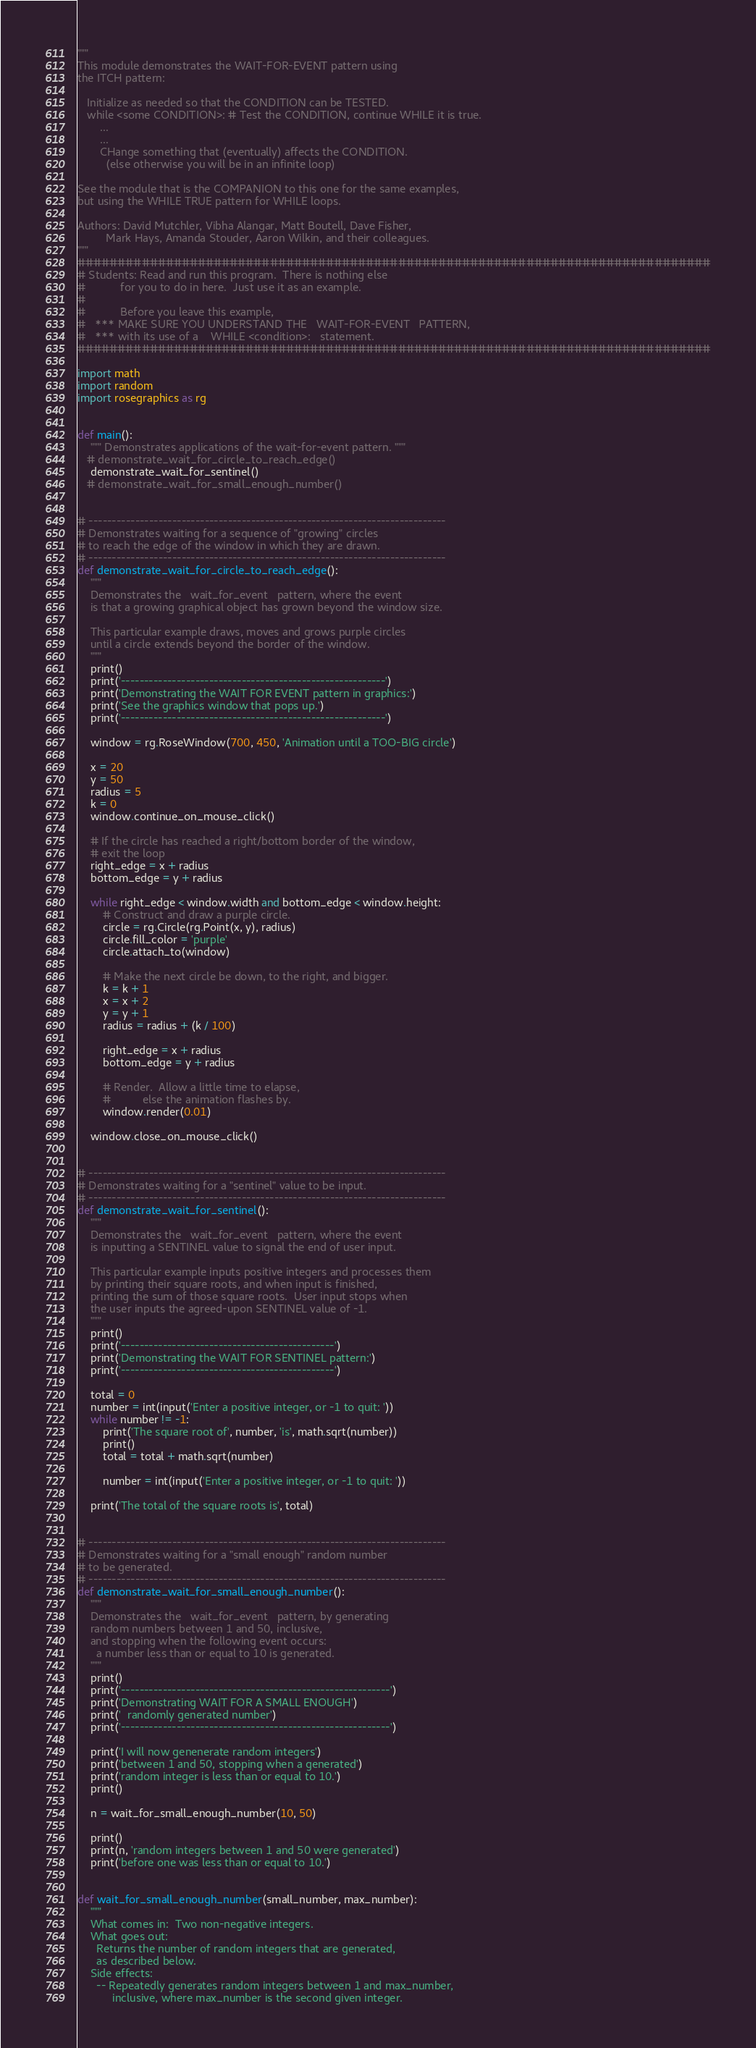<code> <loc_0><loc_0><loc_500><loc_500><_Python_>"""
This module demonstrates the WAIT-FOR-EVENT pattern using
the ITCH pattern:

   Initialize as needed so that the CONDITION can be TESTED.
   while <some CONDITION>: # Test the CONDITION, continue WHILE it is true.
       ...
       ...
       CHange something that (eventually) affects the CONDITION.
         (else otherwise you will be in an infinite loop)

See the module that is the COMPANION to this one for the same examples,
but using the WHILE TRUE pattern for WHILE loops.

Authors: David Mutchler, Vibha Alangar, Matt Boutell, Dave Fisher,
         Mark Hays, Amanda Stouder, Aaron Wilkin, and their colleagues.
"""
###############################################################################
# Students: Read and run this program.  There is nothing else
#           for you to do in here.  Just use it as an example.
#
#           Before you leave this example,
#   *** MAKE SURE YOU UNDERSTAND THE   WAIT-FOR-EVENT   PATTERN,
#   *** with its use of a    WHILE <condition>:   statement.
###############################################################################

import math
import random
import rosegraphics as rg


def main():
    """ Demonstrates applications of the wait-for-event pattern. """
   # demonstrate_wait_for_circle_to_reach_edge()
    demonstrate_wait_for_sentinel()
   # demonstrate_wait_for_small_enough_number()


# -----------------------------------------------------------------------------
# Demonstrates waiting for a sequence of "growing" circles
# to reach the edge of the window in which they are drawn.
# -----------------------------------------------------------------------------
def demonstrate_wait_for_circle_to_reach_edge():
    """
    Demonstrates the   wait_for_event   pattern, where the event
    is that a growing graphical object has grown beyond the window size.

    This particular example draws, moves and grows purple circles
    until a circle extends beyond the border of the window.
    """
    print()
    print('---------------------------------------------------------')
    print('Demonstrating the WAIT FOR EVENT pattern in graphics:')
    print('See the graphics window that pops up.')
    print('---------------------------------------------------------')

    window = rg.RoseWindow(700, 450, 'Animation until a TOO-BIG circle')

    x = 20
    y = 50
    radius = 5
    k = 0
    window.continue_on_mouse_click()

    # If the circle has reached a right/bottom border of the window,
    # exit the loop
    right_edge = x + radius
    bottom_edge = y + radius

    while right_edge < window.width and bottom_edge < window.height:
        # Construct and draw a purple circle.
        circle = rg.Circle(rg.Point(x, y), radius)
        circle.fill_color = 'purple'
        circle.attach_to(window)

        # Make the next circle be down, to the right, and bigger.
        k = k + 1
        x = x + 2
        y = y + 1
        radius = radius + (k / 100)

        right_edge = x + radius
        bottom_edge = y + radius

        # Render.  Allow a little time to elapse,
        #          else the animation flashes by.
        window.render(0.01)

    window.close_on_mouse_click()


# -----------------------------------------------------------------------------
# Demonstrates waiting for a "sentinel" value to be input.
# -----------------------------------------------------------------------------
def demonstrate_wait_for_sentinel():
    """
    Demonstrates the   wait_for_event   pattern, where the event
    is inputting a SENTINEL value to signal the end of user input.

    This particular example inputs positive integers and processes them
    by printing their square roots, and when input is finished,
    printing the sum of those square roots.  User input stops when
    the user inputs the agreed-upon SENTINEL value of -1.
    """
    print()
    print('----------------------------------------------')
    print('Demonstrating the WAIT FOR SENTINEL pattern:')
    print('----------------------------------------------')

    total = 0
    number = int(input('Enter a positive integer, or -1 to quit: '))
    while number != -1:
        print('The square root of', number, 'is', math.sqrt(number))
        print()
        total = total + math.sqrt(number)

        number = int(input('Enter a positive integer, or -1 to quit: '))

    print('The total of the square roots is', total)


# -----------------------------------------------------------------------------
# Demonstrates waiting for a "small enough" random number
# to be generated.
# -----------------------------------------------------------------------------
def demonstrate_wait_for_small_enough_number():
    """
    Demonstrates the   wait_for_event   pattern, by generating
    random numbers between 1 and 50, inclusive,
    and stopping when the following event occurs:
      a number less than or equal to 10 is generated.
    """
    print()
    print('----------------------------------------------------------')
    print('Demonstrating WAIT FOR A SMALL ENOUGH')
    print('  randomly generated number')
    print('----------------------------------------------------------')

    print('I will now genenerate random integers')
    print('between 1 and 50, stopping when a generated')
    print('random integer is less than or equal to 10.')
    print()

    n = wait_for_small_enough_number(10, 50)

    print()
    print(n, 'random integers between 1 and 50 were generated')
    print('before one was less than or equal to 10.')


def wait_for_small_enough_number(small_number, max_number):
    """
    What comes in:  Two non-negative integers.
    What goes out:
      Returns the number of random integers that are generated,
      as described below.
    Side effects:
      -- Repeatedly generates random integers between 1 and max_number,
           inclusive, where max_number is the second given integer.</code> 